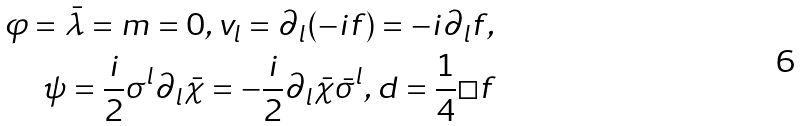Convert formula to latex. <formula><loc_0><loc_0><loc_500><loc_500>\varphi = \bar { \lambda } = m = 0 , v _ { l } = \partial _ { l } ( - i f ) = - i \partial _ { l } f , \\ \psi = \frac { i } { 2 } \sigma ^ { l } \partial _ { l } \bar { \chi } = - \frac { i } { 2 } \partial _ { l } \bar { \chi } \bar { \sigma } ^ { l } , d = \frac { 1 } { 4 } \square f</formula> 